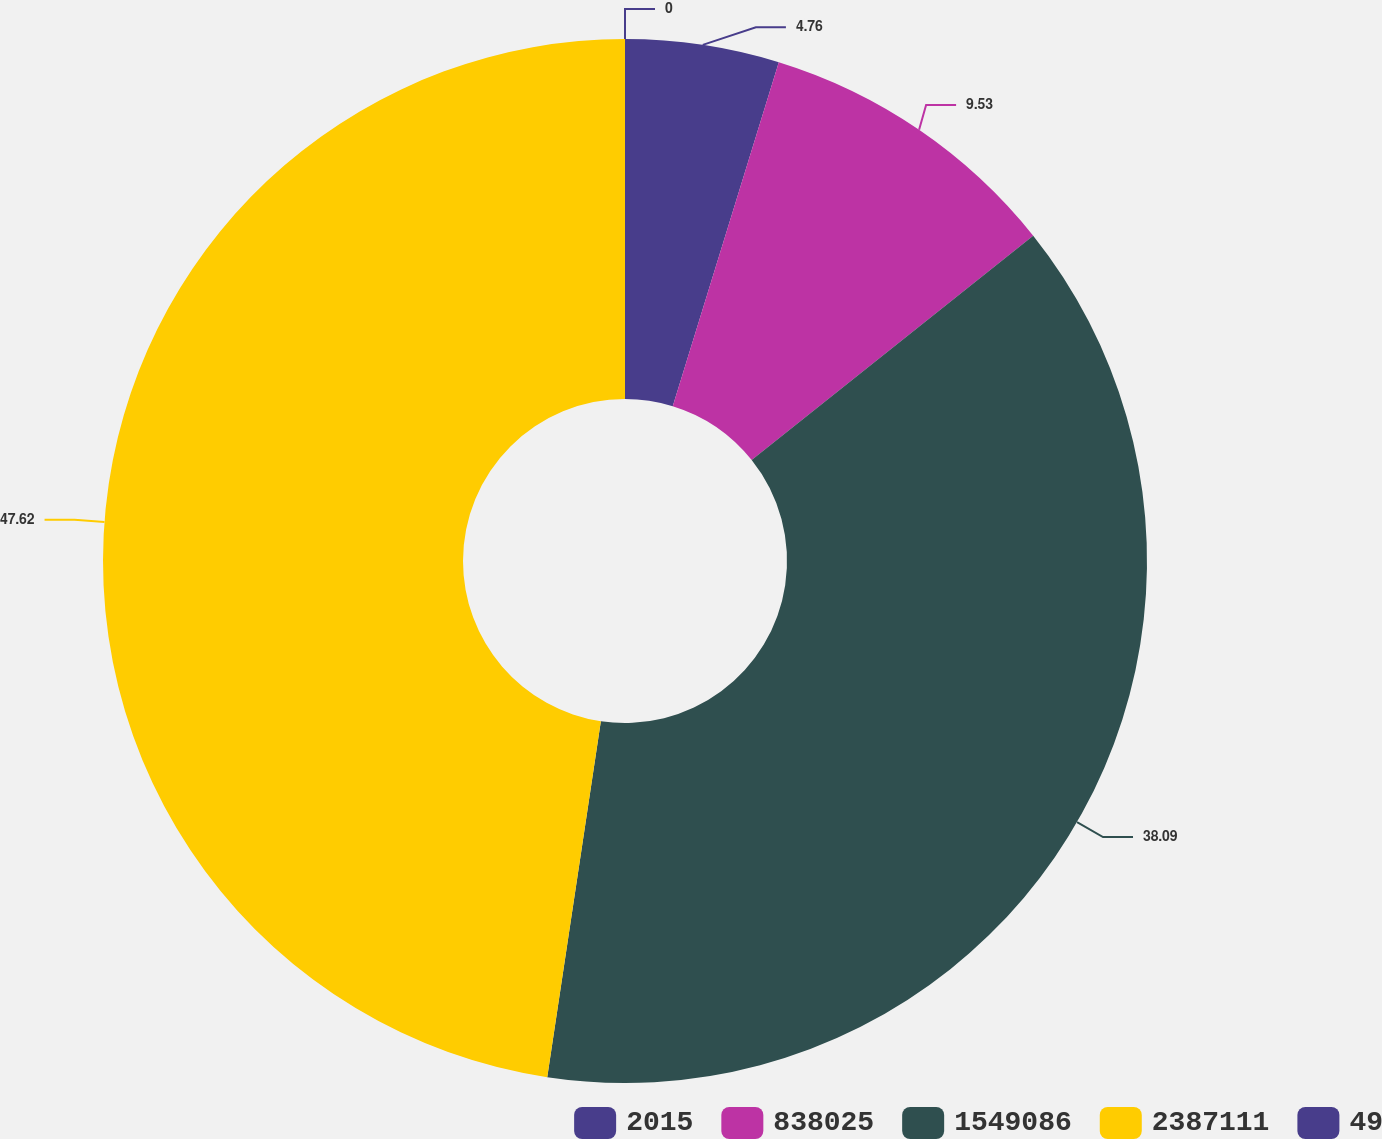Convert chart to OTSL. <chart><loc_0><loc_0><loc_500><loc_500><pie_chart><fcel>2015<fcel>838025<fcel>1549086<fcel>2387111<fcel>49<nl><fcel>4.76%<fcel>9.53%<fcel>38.09%<fcel>47.62%<fcel>0.0%<nl></chart> 